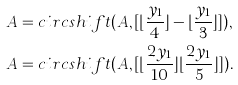<formula> <loc_0><loc_0><loc_500><loc_500>& A = c i r c s h i f t ( A , [ \lfloor \frac { y _ { 1 } } { 4 } \rfloor - \lfloor \frac { y _ { 1 } } { 3 } \rfloor ] ) , \\ & A = c i r c s h i f t ( A , [ \lfloor \frac { 2 y _ { 1 } } { 1 0 } \rfloor \lfloor \frac { 2 y _ { 1 } } { 5 } \rfloor ] ) .</formula> 